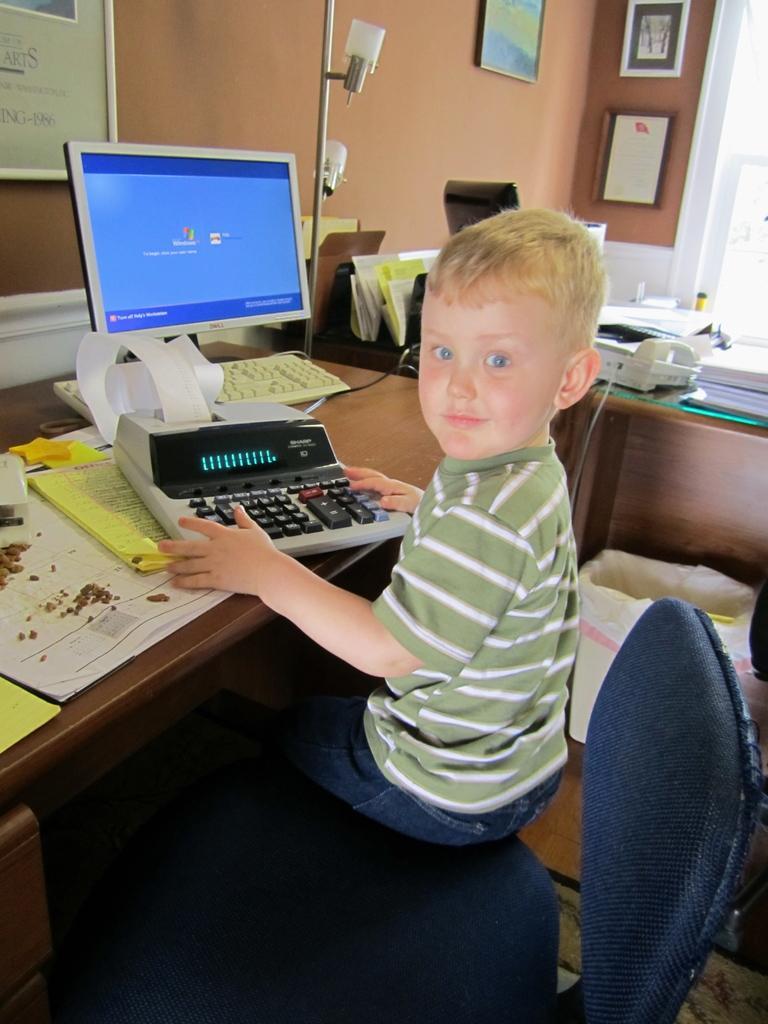In one or two sentences, can you explain what this image depicts? In the middle of the image a kid is sitting on a chair. Top right side of the image there is a wall, On the wall there are two frames. Top left side of the image there is a wall on the wall there is a board. In the middle of the image there is a desktop. Bottom left side of the image there is a table, on the table there is a electronic device and some papers. 